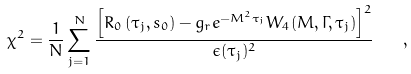<formula> <loc_0><loc_0><loc_500><loc_500>\chi ^ { 2 } = \frac { 1 } { N } \sum _ { j = 1 } ^ { N } \frac { \left [ { R } _ { 0 } \left ( \tau _ { j } , s _ { 0 } \right ) - g _ { r } e ^ { - M ^ { 2 } \tau _ { j } } W _ { 4 } ( M , \Gamma , \tau _ { j } ) \right ] ^ { 2 } } { \epsilon ( \tau _ { j } ) ^ { 2 } } \quad ,</formula> 